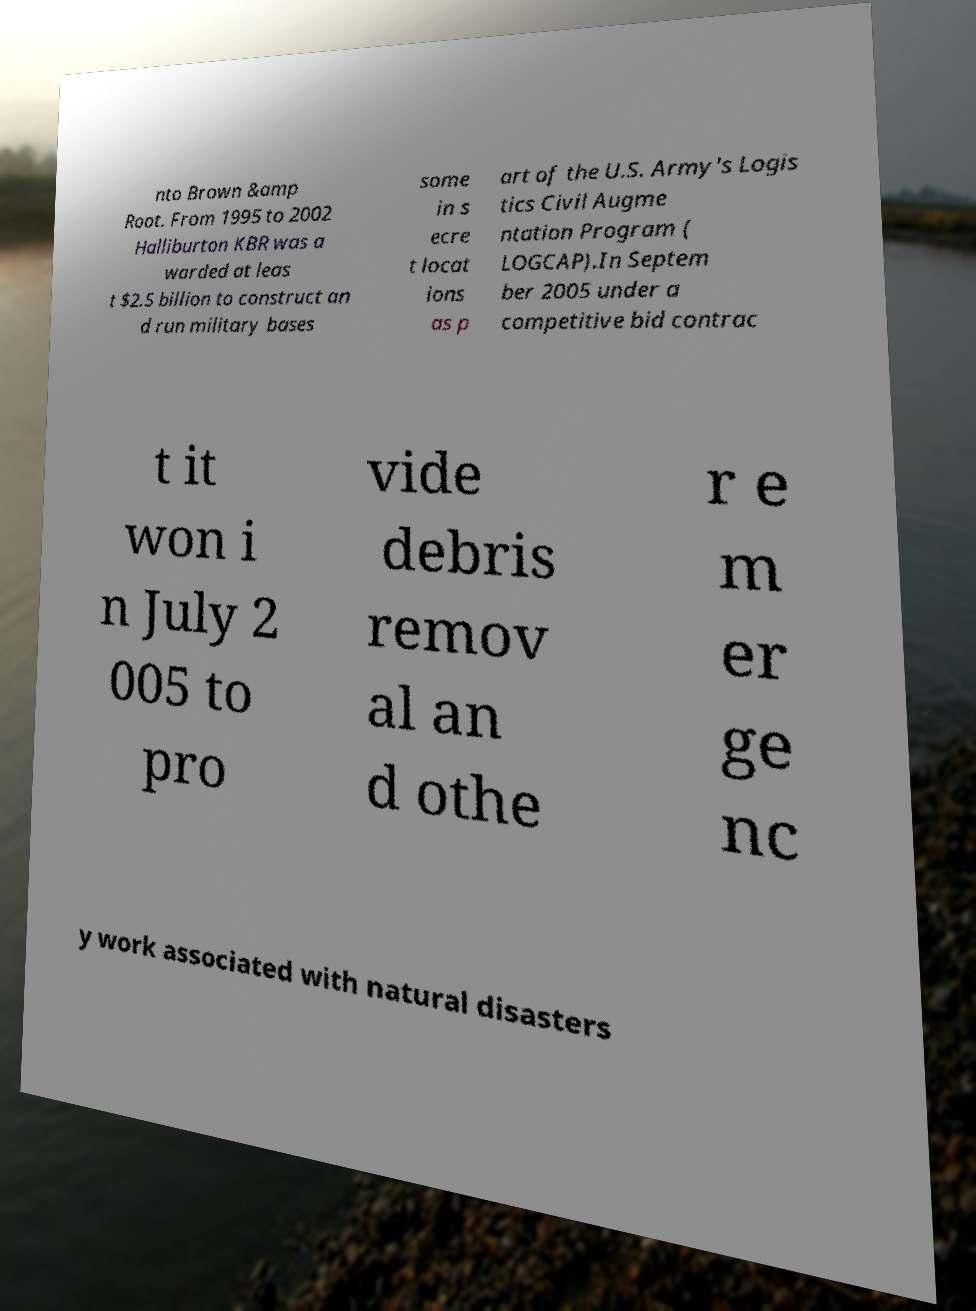Can you accurately transcribe the text from the provided image for me? nto Brown &amp Root. From 1995 to 2002 Halliburton KBR was a warded at leas t $2.5 billion to construct an d run military bases some in s ecre t locat ions as p art of the U.S. Army's Logis tics Civil Augme ntation Program ( LOGCAP).In Septem ber 2005 under a competitive bid contrac t it won i n July 2 005 to pro vide debris remov al an d othe r e m er ge nc y work associated with natural disasters 